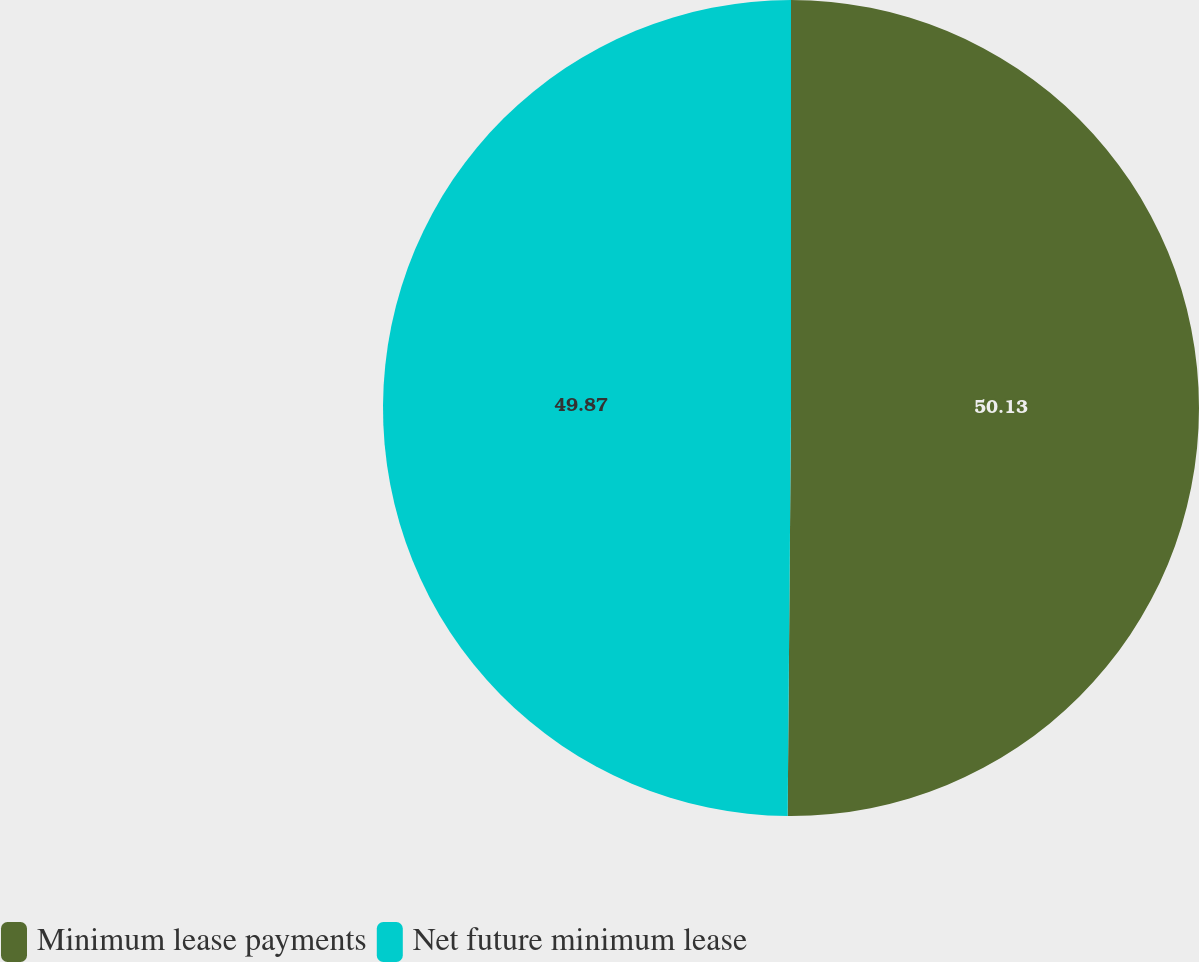Convert chart to OTSL. <chart><loc_0><loc_0><loc_500><loc_500><pie_chart><fcel>Minimum lease payments<fcel>Net future minimum lease<nl><fcel>50.13%<fcel>49.87%<nl></chart> 